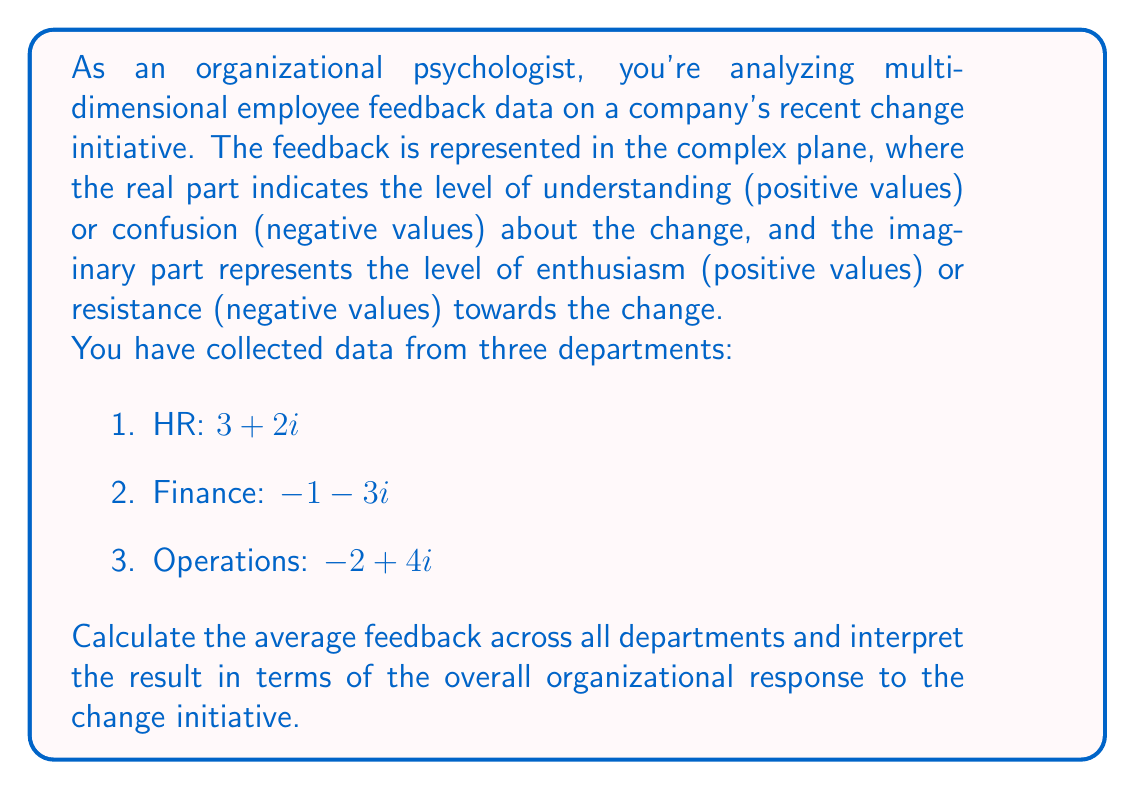Give your solution to this math problem. To solve this problem, we need to perform complex number operations:

1. First, we add the complex numbers representing feedback from each department:

   $$(3 + 2i) + (-1 - 3i) + (-2 + 4i)$$

2. Combine real and imaginary parts separately:

   $$(3 - 1 - 2) + (2 - 3 + 4)i$$
   
   $$= 0 + 3i$$

3. To find the average, we divide the sum by the number of departments (3):

   $$\frac{0 + 3i}{3} = 0 + i$$

Interpretation:
- The real part (0) indicates that, on average, there is a neutral level of understanding about the change initiative across the organization.
- The imaginary part (+1) suggests a slightly positive level of enthusiasm towards the change.

This result indicates that while employees, on average, neither clearly understand nor misunderstand the change, there is a slight tendency towards enthusiasm rather than resistance.
Answer: The average feedback across all departments is $0 + i$, indicating neutral understanding and slightly positive enthusiasm towards the change initiative. 